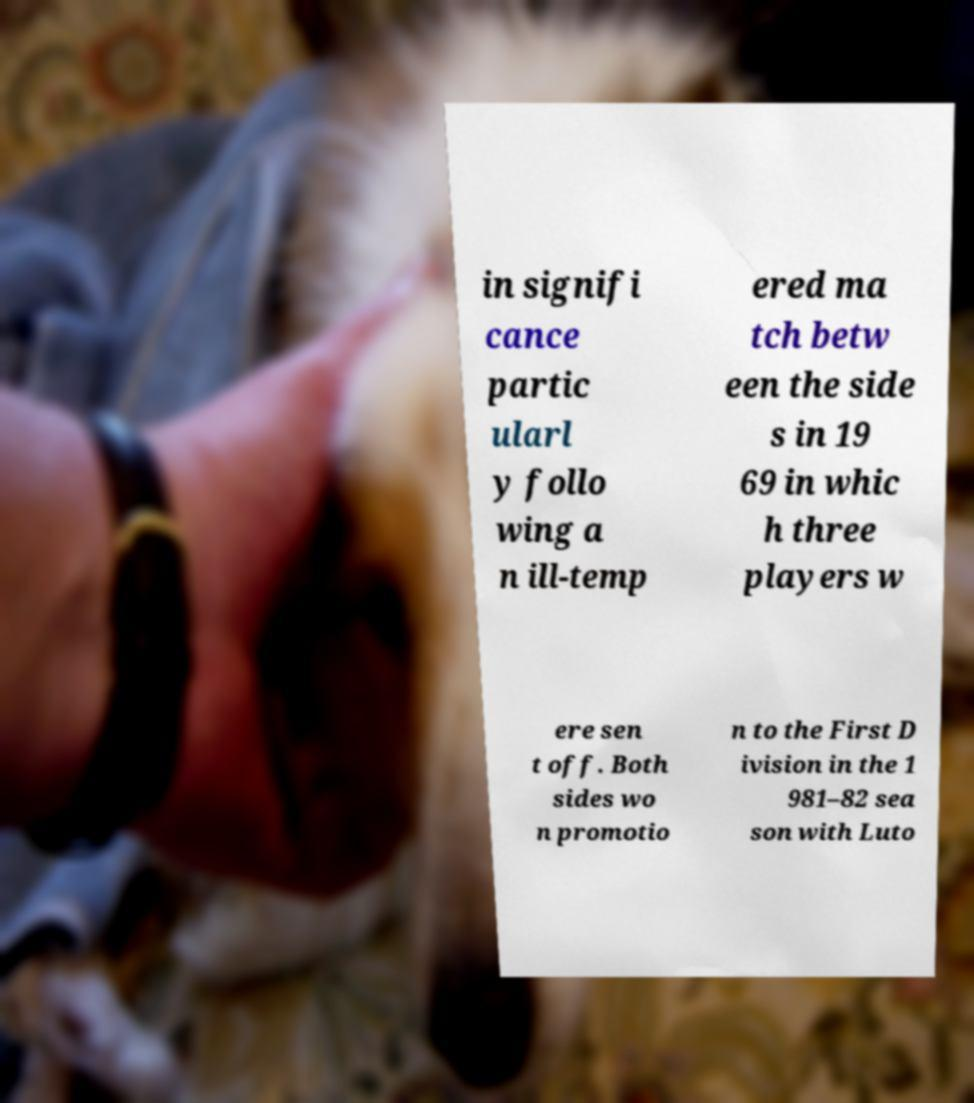Can you read and provide the text displayed in the image?This photo seems to have some interesting text. Can you extract and type it out for me? in signifi cance partic ularl y follo wing a n ill-temp ered ma tch betw een the side s in 19 69 in whic h three players w ere sen t off. Both sides wo n promotio n to the First D ivision in the 1 981–82 sea son with Luto 